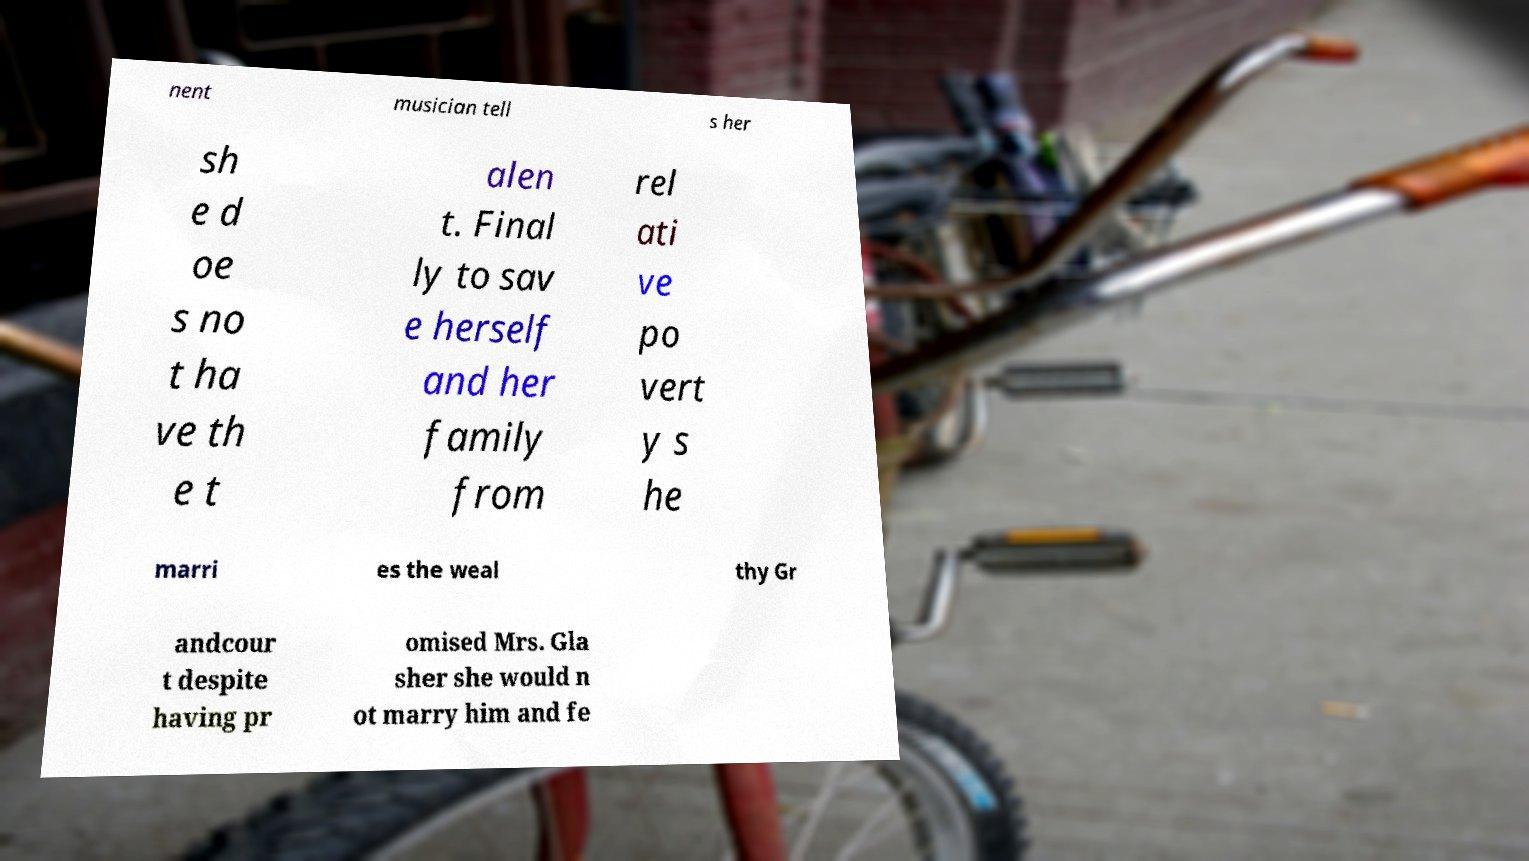Please identify and transcribe the text found in this image. nent musician tell s her sh e d oe s no t ha ve th e t alen t. Final ly to sav e herself and her family from rel ati ve po vert y s he marri es the weal thy Gr andcour t despite having pr omised Mrs. Gla sher she would n ot marry him and fe 